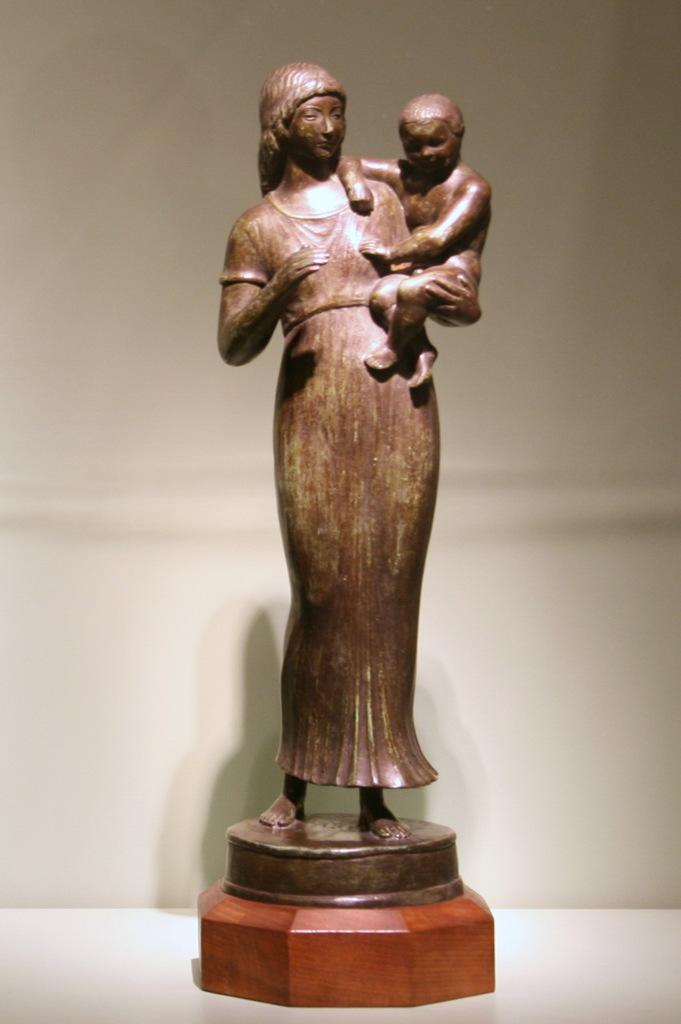What is the color of the mannequin in the image? The mannequin is brown in color. What gender is the mannequin representing? The mannequin is a woman. What is the woman holding in the image? The woman is holding a baby. What is the background color in the image? The background color is white. Can you see a tiger in the image? No, there is no tiger present in the image. What time of day is it in the image? The time of day is not mentioned or depicted in the image, so it cannot be determined. 